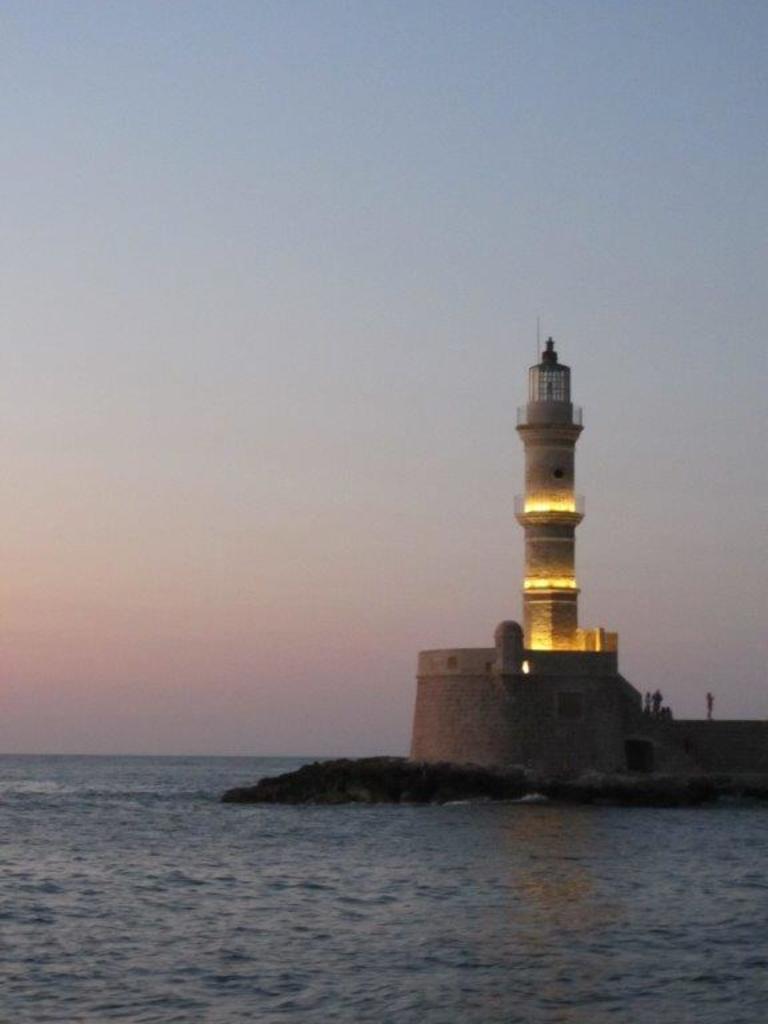Could you give a brief overview of what you see in this image? In this image there is a lighthouse with people standing on it, around the lighthouse there is water. 